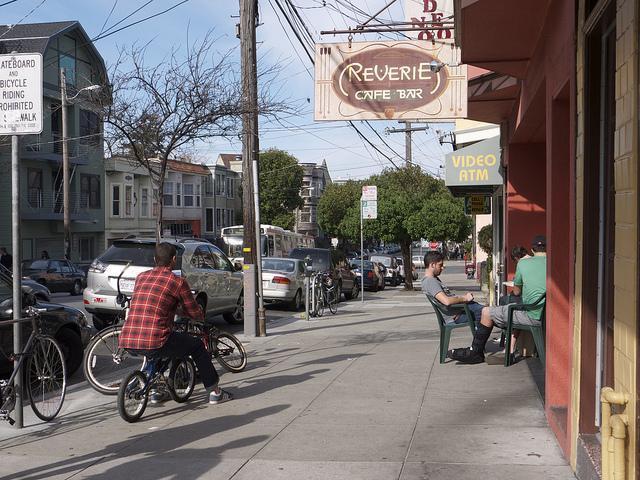What can the men do here?
Indicate the correct response and explain using: 'Answer: answer
Rationale: rationale.'
Options: Ride, haircut, compete, drink. Answer: drink.
Rationale: They are outside a bar. 